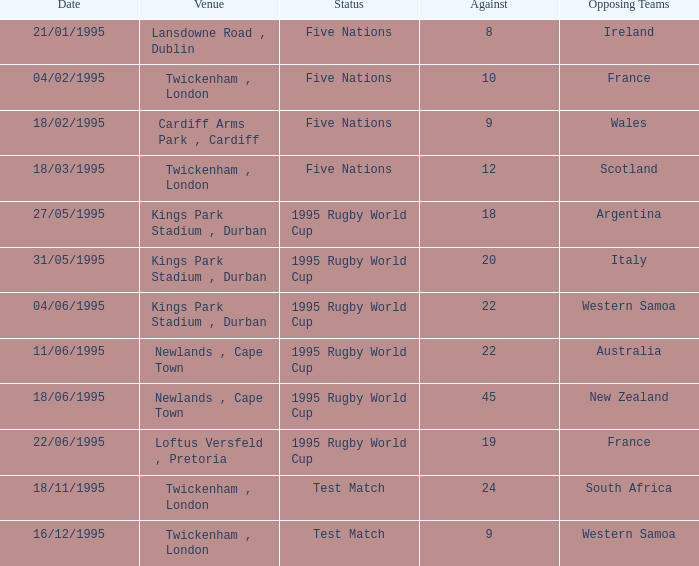What's the total against for opposing team scotland at twickenham, london venue with a status of five nations? 1.0. 